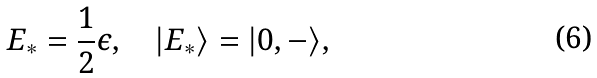Convert formula to latex. <formula><loc_0><loc_0><loc_500><loc_500>E _ { * } = \frac { 1 } { 2 } \epsilon , \quad | E _ { * } \rangle = | 0 , - \rangle ,</formula> 